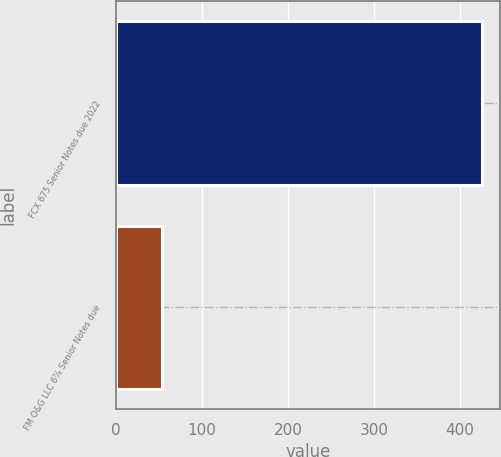Convert chart. <chart><loc_0><loc_0><loc_500><loc_500><bar_chart><fcel>FCX 675 Senior Notes due 2022<fcel>FM O&G LLC 6⅞ Senior Notes due<nl><fcel>426<fcel>54<nl></chart> 